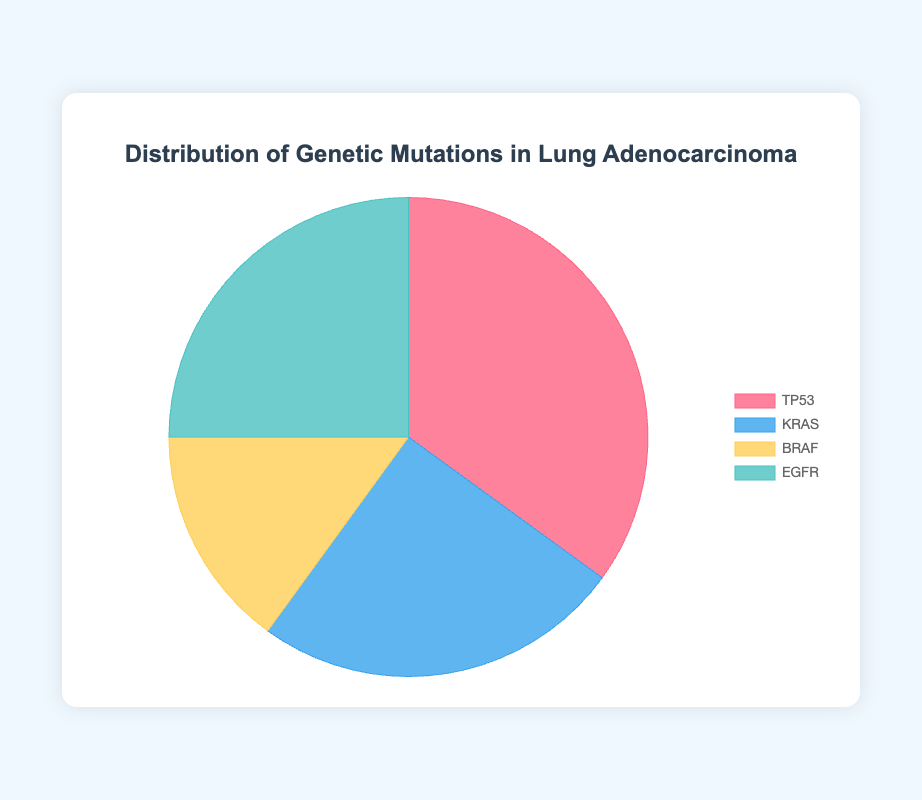What percentage of Lung Adenocarcinoma samples have TP53 mutations? The figure shows the percentage distribution for each genetic mutation. Locate the slice labeled "TP53" to find its percentage.
Answer: 35% Which two genetic mutations have an equal distribution in Lung Adenocarcinoma? Look at the figure for slices with the same size and corresponding labels. The slices for KRAS and EGFR both show the same percentage.
Answer: KRAS and EGFR What is the combined percentage of KRAS and BRAF mutations? Find the slices labeled "KRAS" and "BRAF" and add their percentages (25% + 15%).
Answer: 40% Is the percentage of EGFR mutations greater than the percentage of BRAF mutations? Compare the size of the slices labeled "EGFR" and "BRAF". EGFR has 25% while BRAF has 15%.
Answer: Yes Which genetic mutation has the smallest representation in Lung Adenocarcinoma? Identify the slice in the figure with the smallest size. The BRAF slice is the smallest with 15%.
Answer: BRAF What is the sum percentage of TP53 and KRAS mutations? Look at the slices for TP53 and KRAS and add their percentages (35% + 25%).
Answer: 60% Which genetic mutation is depicted in red in the figure? Observe the colors of the slices and match the red color to its label. The red slice represents TP53.
Answer: TP53 By how much does the TP53 mutation percentage exceed the average percentage of all four mutations? First, calculate the mean percentage: (35% + 25% + 15% + 25%) / 4 = 25%. Then, subtract this average from the TP53 percentage: 35% - 25%.
Answer: 10% What is the total percentage of all four genetic mutations shown? Add the percentages of TP53, KRAS, BRAF, and EGFR (35% + 25% + 15% + 25%).
Answer: 100% 